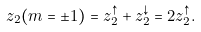Convert formula to latex. <formula><loc_0><loc_0><loc_500><loc_500>z _ { 2 } ( m = \pm 1 ) = z _ { 2 } ^ { \uparrow } + z _ { 2 } ^ { \downarrow } = 2 z _ { 2 } ^ { \uparrow } .</formula> 